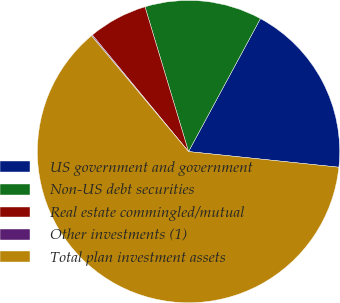Convert chart. <chart><loc_0><loc_0><loc_500><loc_500><pie_chart><fcel>US government and government<fcel>Non-US debt securities<fcel>Real estate commingled/mutual<fcel>Other investments (1)<fcel>Total plan investment assets<nl><fcel>18.76%<fcel>12.54%<fcel>6.33%<fcel>0.12%<fcel>62.25%<nl></chart> 